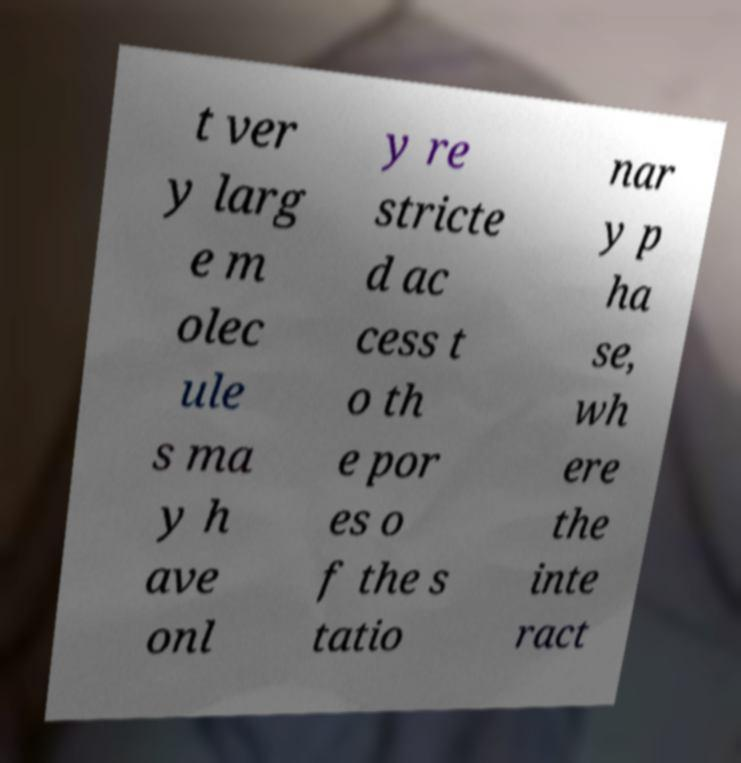Could you extract and type out the text from this image? t ver y larg e m olec ule s ma y h ave onl y re stricte d ac cess t o th e por es o f the s tatio nar y p ha se, wh ere the inte ract 